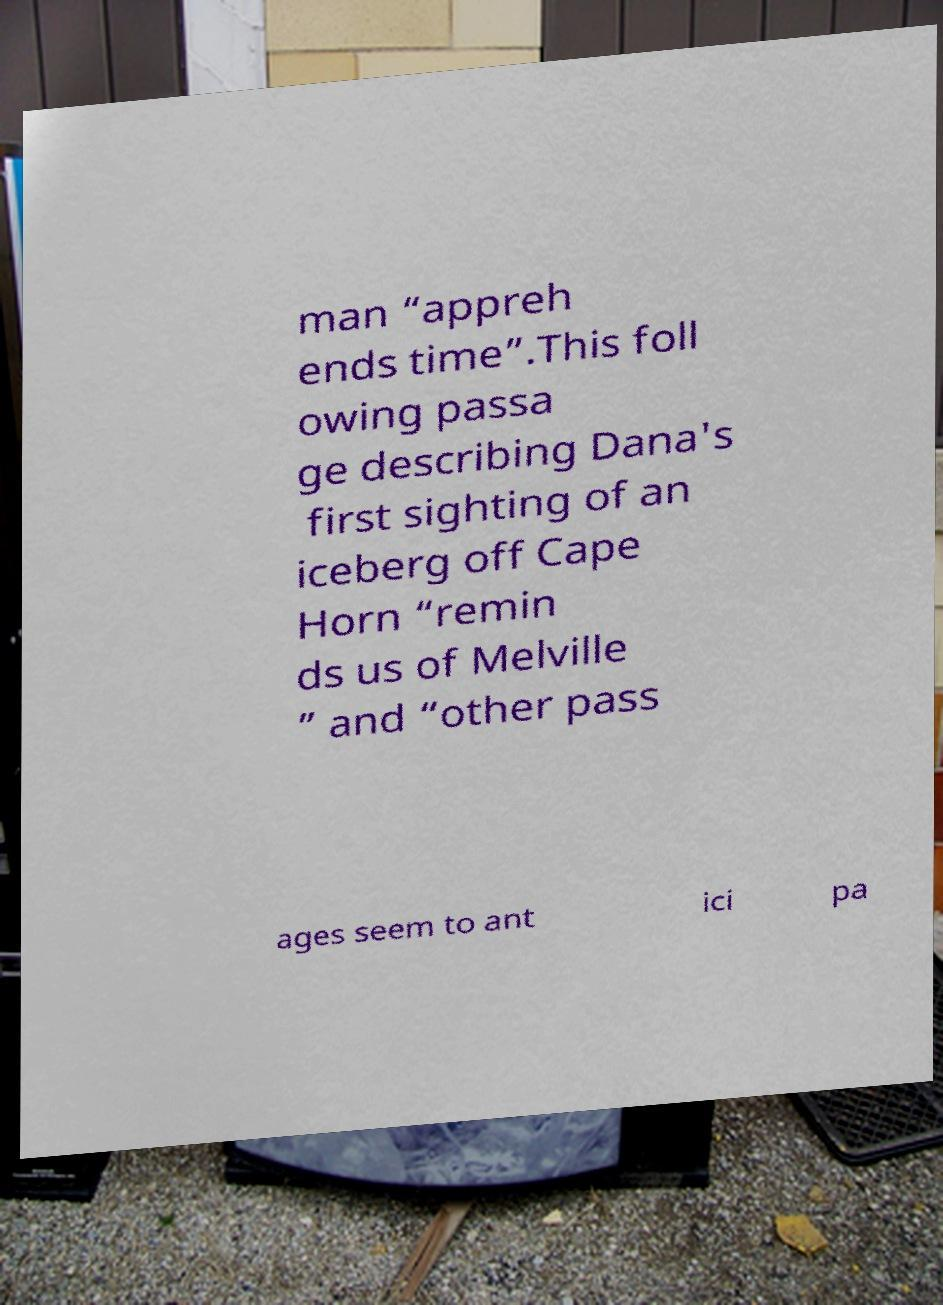For documentation purposes, I need the text within this image transcribed. Could you provide that? man “appreh ends time”.This foll owing passa ge describing Dana's first sighting of an iceberg off Cape Horn “remin ds us of Melville ” and “other pass ages seem to ant ici pa 